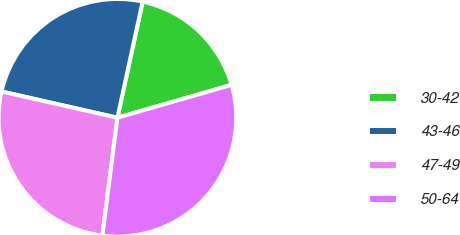Convert chart to OTSL. <chart><loc_0><loc_0><loc_500><loc_500><pie_chart><fcel>30-42<fcel>43-46<fcel>47-49<fcel>50-64<nl><fcel>17.13%<fcel>24.86%<fcel>26.52%<fcel>31.49%<nl></chart> 